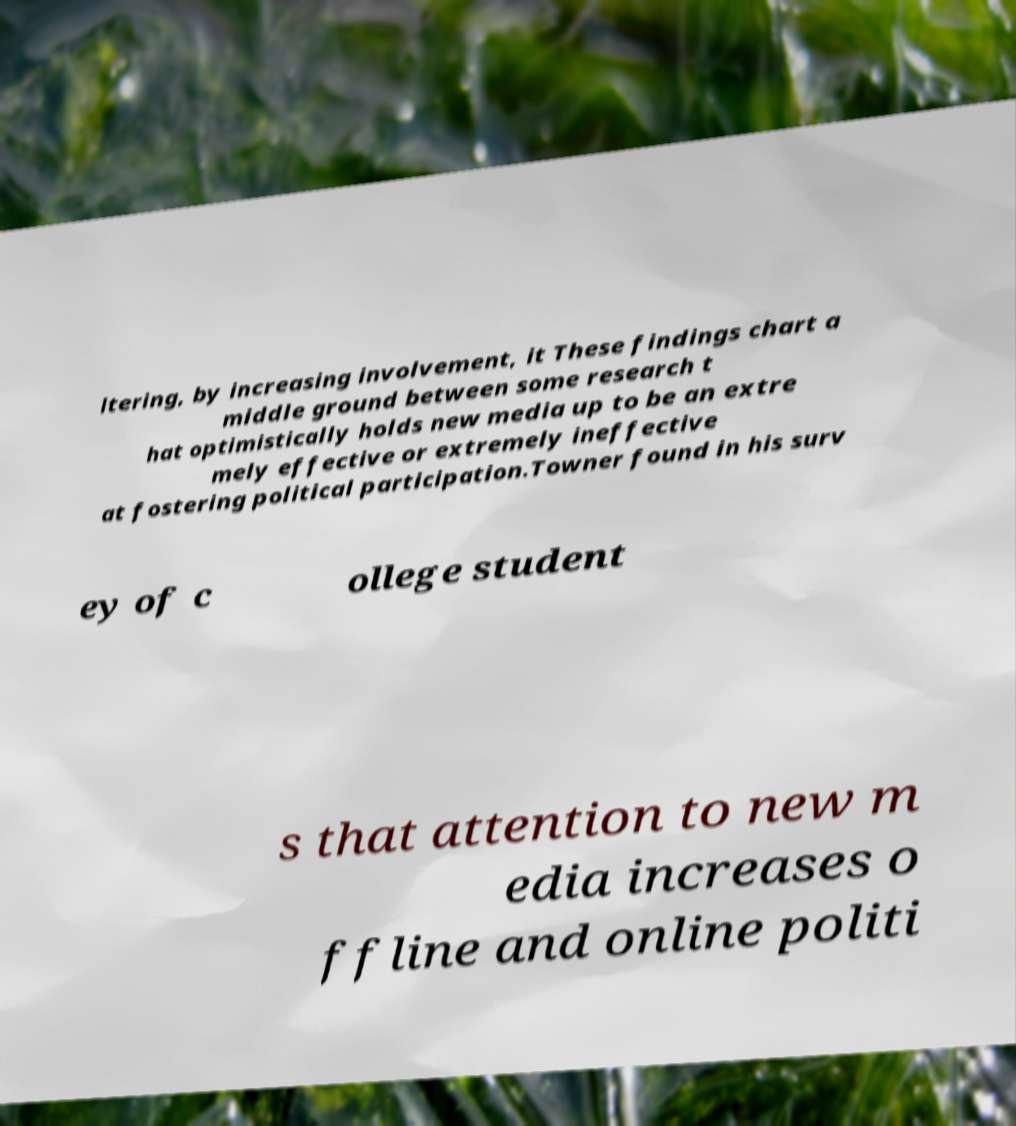Can you accurately transcribe the text from the provided image for me? ltering, by increasing involvement, it These findings chart a middle ground between some research t hat optimistically holds new media up to be an extre mely effective or extremely ineffective at fostering political participation.Towner found in his surv ey of c ollege student s that attention to new m edia increases o ffline and online politi 